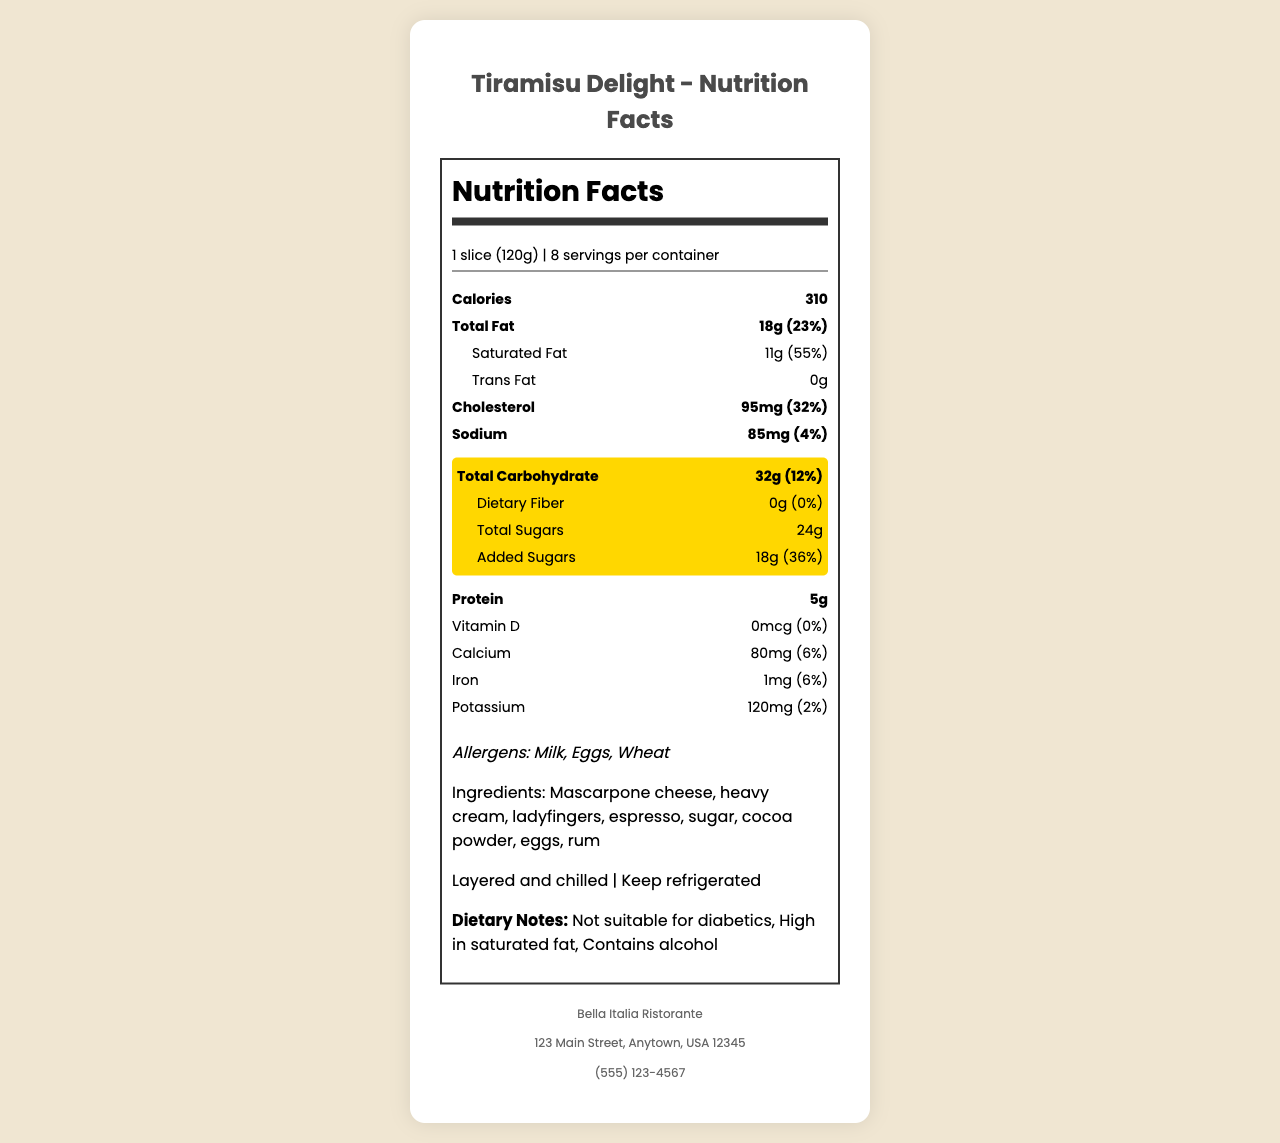what is the serving size for Tiramisu Delight? The serving size is specified at the beginning of the document.
Answer: 1 slice (120g) how many servings per container are included in Tiramisu Delight? The document states that there are 8 servings per container.
Answer: 8 what is the total carbohydrate content for one serving of Tiramisu Delight? The document specifies that the total carbohydrate content is 32g per serving.
Answer: 32g how much sugar is in one serving of Tiramisu Delight? The document shows that total sugars per serving amount to 24g.
Answer: 24g how much added sugar does Tiramisu Delight contain? The document indicates that there are 18g of added sugars per serving.
Answer: 18g what is the percentage daily value of total carbohydrates in one serving? The document states that the daily value percentage for total carbohydrates in one serving is 12%.
Answer: 12% which allergen is NOT listed in Tiramisu Delight? A. Milk B. Nuts C. Eggs The document lists Milk, Eggs, and Wheat as allergens, but not Nuts.
Answer: B what is the preparation method for Tiramisu Delight? A. Baked B. Fried C. Layered and chilled The document explicitly states that the preparation method is layered and chilled.
Answer: C does the Tiramisu Delight contain alcohol? The dietary notes explicitly state that the dessert contains alcohol.
Answer: Yes describe the entire document The document consists of a comprehensive nutrition facts label providing all relevant nutritional information, ingredients, and other pertinent details for the restaurant signature dessert - Tiramisu Delight.
Answer: This is a nutrition facts label for Tiramisu Delight, including serving size, number of servings, and detailed nutritional information such as fats, carbohydrates, proteins, vitamins, and minerals. It lists allergens, ingredients, preparation and storage instructions, and dietary notes along with the restaurant's contact information. how many grams of dietary fiber are in one serving of Tiramisu Delight? The document explicitly states that there is 0g of dietary fiber per serving.
Answer: 0g how many milligrams of potassium are in one serving of Tiramisu Delight? The document specifies the potassium content as 120mg per serving.
Answer: 120mg what is the main ingredient in Tiramisu Delight? The document lists multiple ingredients, so it's not clear which one is considered the main ingredient.
Answer: Not enough information is Tiramisu Delight a low-sodium food? The daily value percentage for sodium is 4%, which is not considered low according to standard nutrition guidelines (typically, a 5% DV or less is low).
Answer: No 